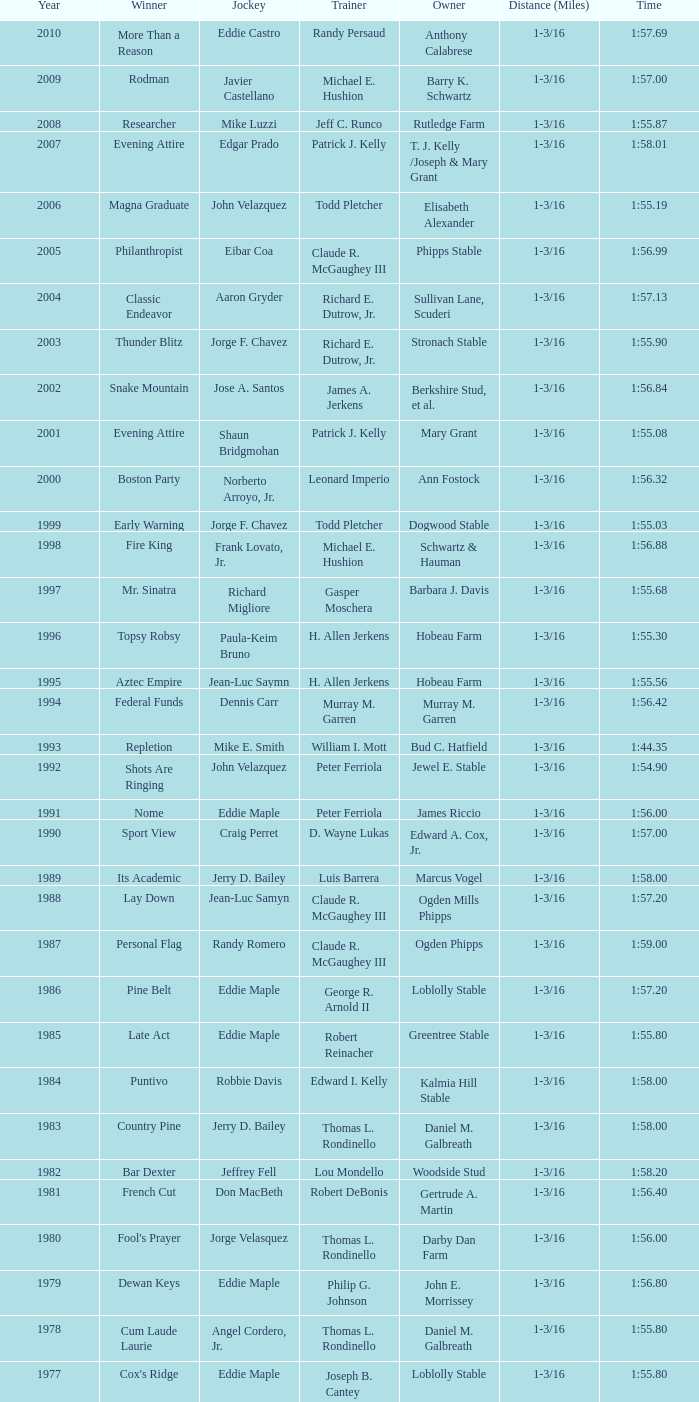Who was the jockey for the winning horse Helioptic? Paul Miller. 